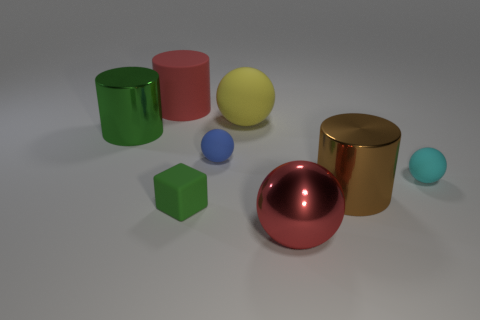There is a small cyan rubber ball; are there any large green metallic things on the right side of it?
Give a very brief answer. No. There is a rubber thing that is the same shape as the brown metallic thing; what is its size?
Make the answer very short. Large. Are there any other things that have the same size as the yellow ball?
Give a very brief answer. Yes. Is the big yellow rubber object the same shape as the big brown shiny object?
Ensure brevity in your answer.  No. What size is the thing behind the big yellow rubber object behind the red metal sphere?
Provide a short and direct response. Large. There is another big metallic object that is the same shape as the brown metallic object; what color is it?
Make the answer very short. Green. How many matte cylinders have the same color as the large rubber sphere?
Your answer should be very brief. 0. What size is the red rubber cylinder?
Make the answer very short. Large. Is the size of the blue matte thing the same as the matte cylinder?
Offer a very short reply. No. What color is the small matte object that is behind the brown shiny cylinder and on the left side of the cyan matte thing?
Give a very brief answer. Blue. 